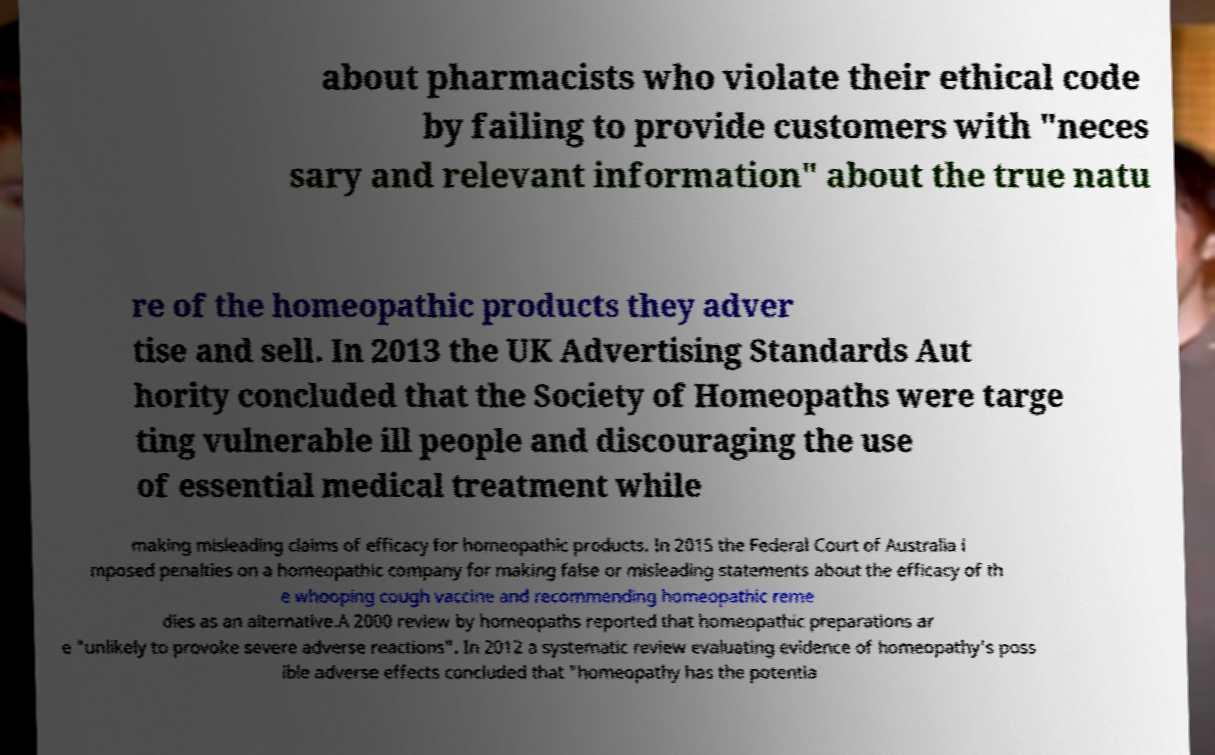Can you accurately transcribe the text from the provided image for me? about pharmacists who violate their ethical code by failing to provide customers with "neces sary and relevant information" about the true natu re of the homeopathic products they adver tise and sell. In 2013 the UK Advertising Standards Aut hority concluded that the Society of Homeopaths were targe ting vulnerable ill people and discouraging the use of essential medical treatment while making misleading claims of efficacy for homeopathic products. In 2015 the Federal Court of Australia i mposed penalties on a homeopathic company for making false or misleading statements about the efficacy of th e whooping cough vaccine and recommending homeopathic reme dies as an alternative.A 2000 review by homeopaths reported that homeopathic preparations ar e "unlikely to provoke severe adverse reactions". In 2012 a systematic review evaluating evidence of homeopathy's poss ible adverse effects concluded that "homeopathy has the potentia 